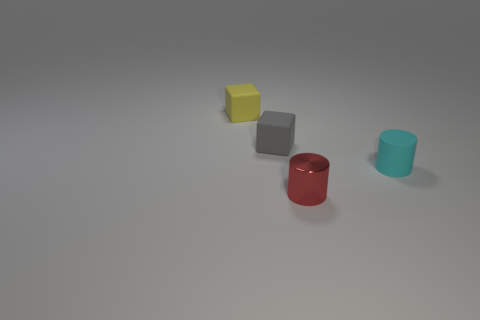Subtract 1 blocks. How many blocks are left? 1 Subtract all purple cubes. Subtract all green cylinders. How many cubes are left? 2 Subtract all yellow cylinders. How many brown cubes are left? 0 Subtract all large yellow shiny blocks. Subtract all tiny metallic objects. How many objects are left? 3 Add 3 small matte blocks. How many small matte blocks are left? 5 Add 4 rubber things. How many rubber things exist? 7 Add 1 small yellow metallic objects. How many objects exist? 5 Subtract 0 green blocks. How many objects are left? 4 